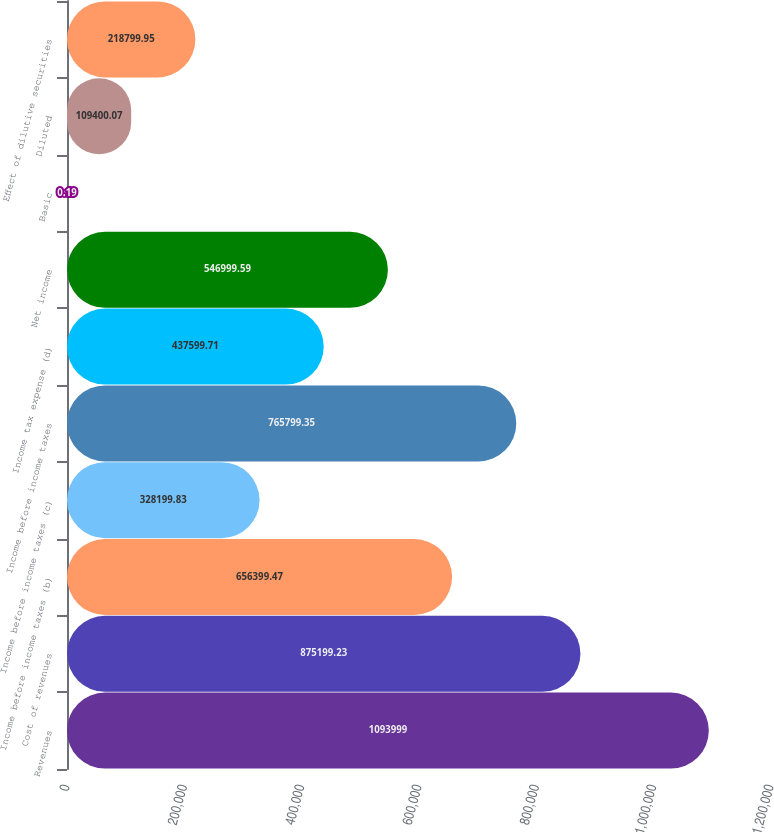Convert chart to OTSL. <chart><loc_0><loc_0><loc_500><loc_500><bar_chart><fcel>Revenues<fcel>Cost of revenues<fcel>Income before income taxes (b)<fcel>Income before income taxes (c)<fcel>Income before income taxes<fcel>Income tax expense (d)<fcel>Net income<fcel>Basic<fcel>Diluted<fcel>Effect of dilutive securities<nl><fcel>1.094e+06<fcel>875199<fcel>656399<fcel>328200<fcel>765799<fcel>437600<fcel>547000<fcel>0.19<fcel>109400<fcel>218800<nl></chart> 